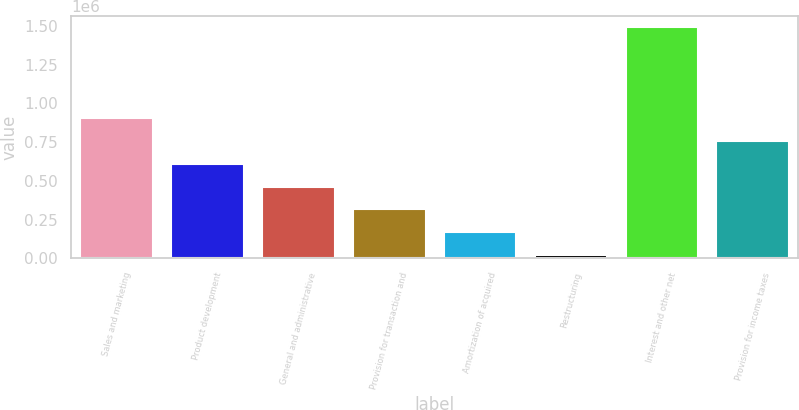<chart> <loc_0><loc_0><loc_500><loc_500><bar_chart><fcel>Sales and marketing<fcel>Product development<fcel>General and administrative<fcel>Provision for transaction and<fcel>Amortization of acquired<fcel>Restructuring<fcel>Interest and other net<fcel>Provision for income taxes<nl><fcel>903779<fcel>609828<fcel>462852<fcel>315877<fcel>168902<fcel>21926<fcel>1.49168e+06<fcel>756804<nl></chart> 